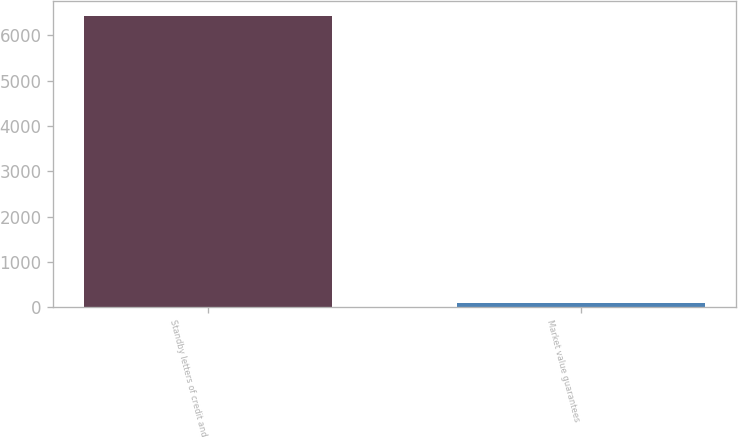Convert chart to OTSL. <chart><loc_0><loc_0><loc_500><loc_500><bar_chart><fcel>Standby letters of credit and<fcel>Market value guarantees<nl><fcel>6434<fcel>88<nl></chart> 